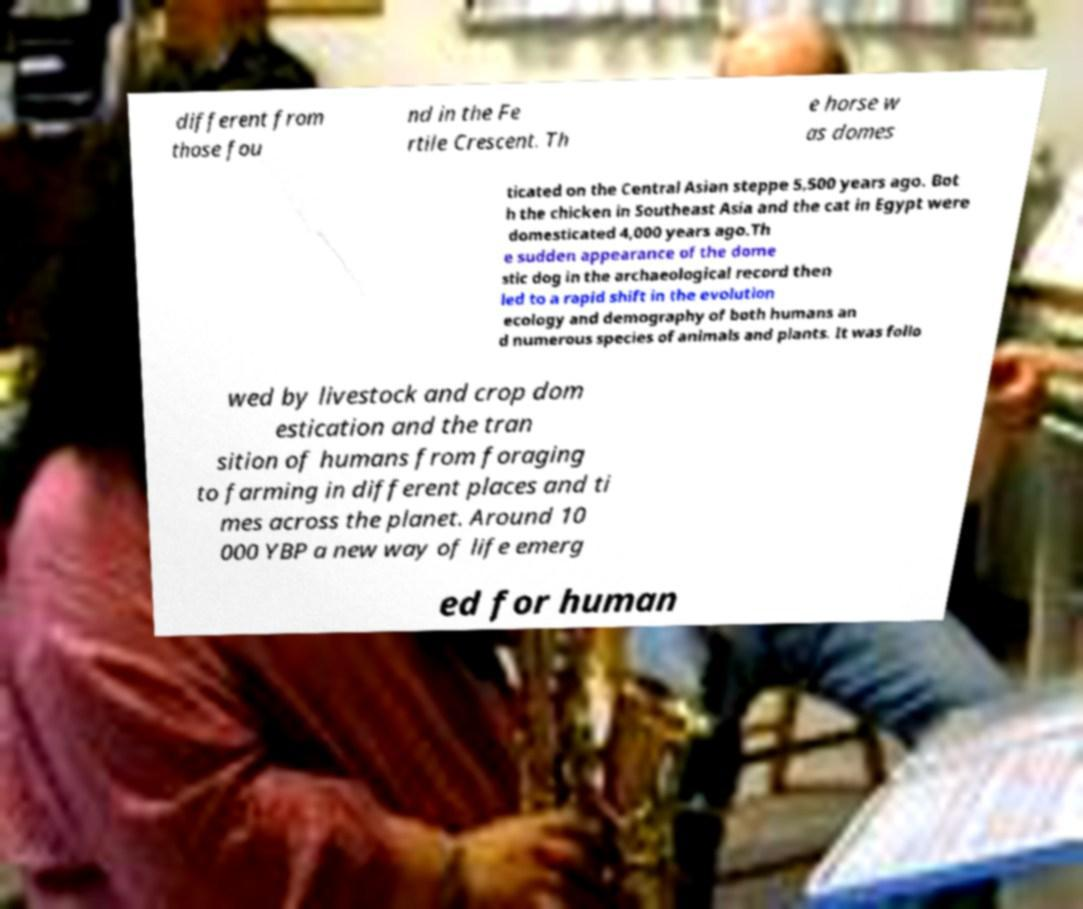I need the written content from this picture converted into text. Can you do that? different from those fou nd in the Fe rtile Crescent. Th e horse w as domes ticated on the Central Asian steppe 5,500 years ago. Bot h the chicken in Southeast Asia and the cat in Egypt were domesticated 4,000 years ago.Th e sudden appearance of the dome stic dog in the archaeological record then led to a rapid shift in the evolution ecology and demography of both humans an d numerous species of animals and plants. It was follo wed by livestock and crop dom estication and the tran sition of humans from foraging to farming in different places and ti mes across the planet. Around 10 000 YBP a new way of life emerg ed for human 